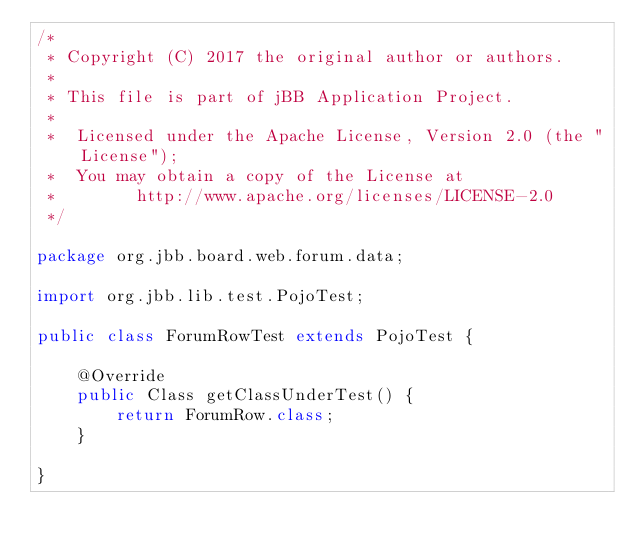Convert code to text. <code><loc_0><loc_0><loc_500><loc_500><_Java_>/*
 * Copyright (C) 2017 the original author or authors.
 *
 * This file is part of jBB Application Project.
 *
 *  Licensed under the Apache License, Version 2.0 (the "License");
 *  You may obtain a copy of the License at
 *        http://www.apache.org/licenses/LICENSE-2.0
 */

package org.jbb.board.web.forum.data;

import org.jbb.lib.test.PojoTest;

public class ForumRowTest extends PojoTest {

    @Override
    public Class getClassUnderTest() {
        return ForumRow.class;
    }

}</code> 